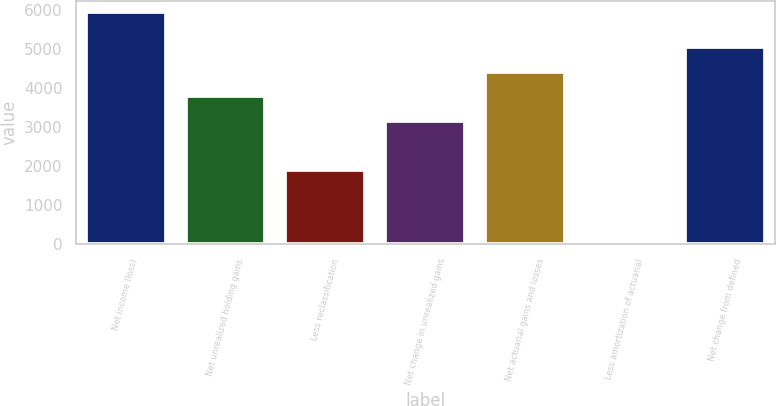Convert chart to OTSL. <chart><loc_0><loc_0><loc_500><loc_500><bar_chart><fcel>Net income (loss)<fcel>Net unrealized holding gains<fcel>Less reclassification<fcel>Net change in unrealized gains<fcel>Net actuarial gains and losses<fcel>Less amortization of actuarial<fcel>Net change from defined<nl><fcel>5951<fcel>3789<fcel>1896<fcel>3158<fcel>4420<fcel>3<fcel>5051<nl></chart> 